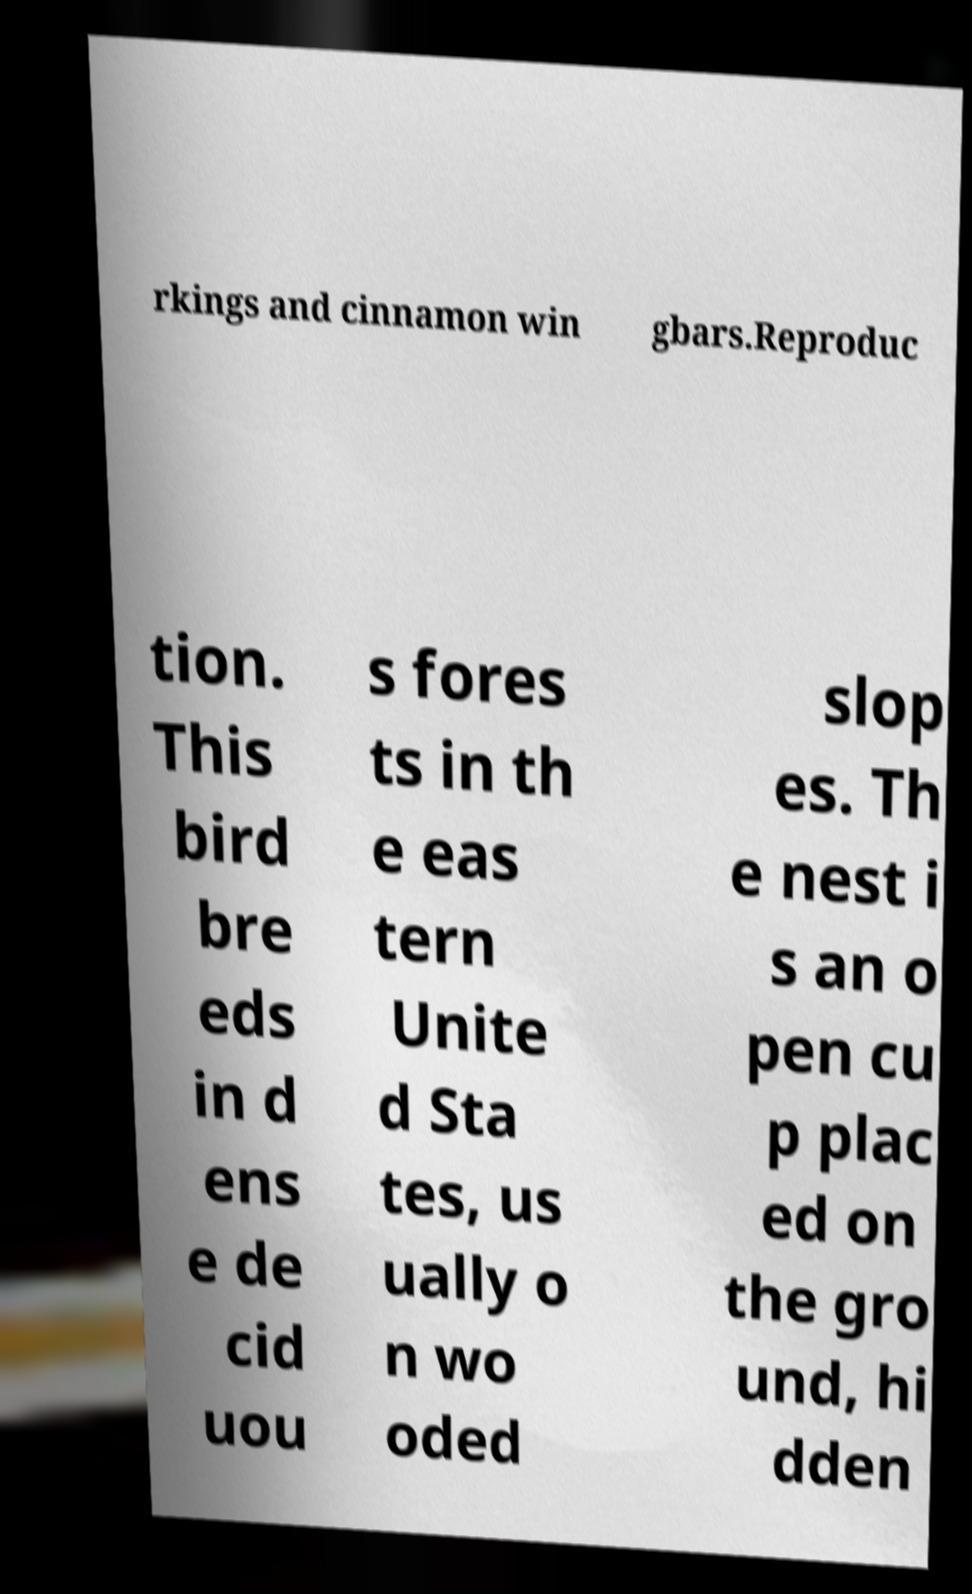For documentation purposes, I need the text within this image transcribed. Could you provide that? rkings and cinnamon win gbars.Reproduc tion. This bird bre eds in d ens e de cid uou s fores ts in th e eas tern Unite d Sta tes, us ually o n wo oded slop es. Th e nest i s an o pen cu p plac ed on the gro und, hi dden 